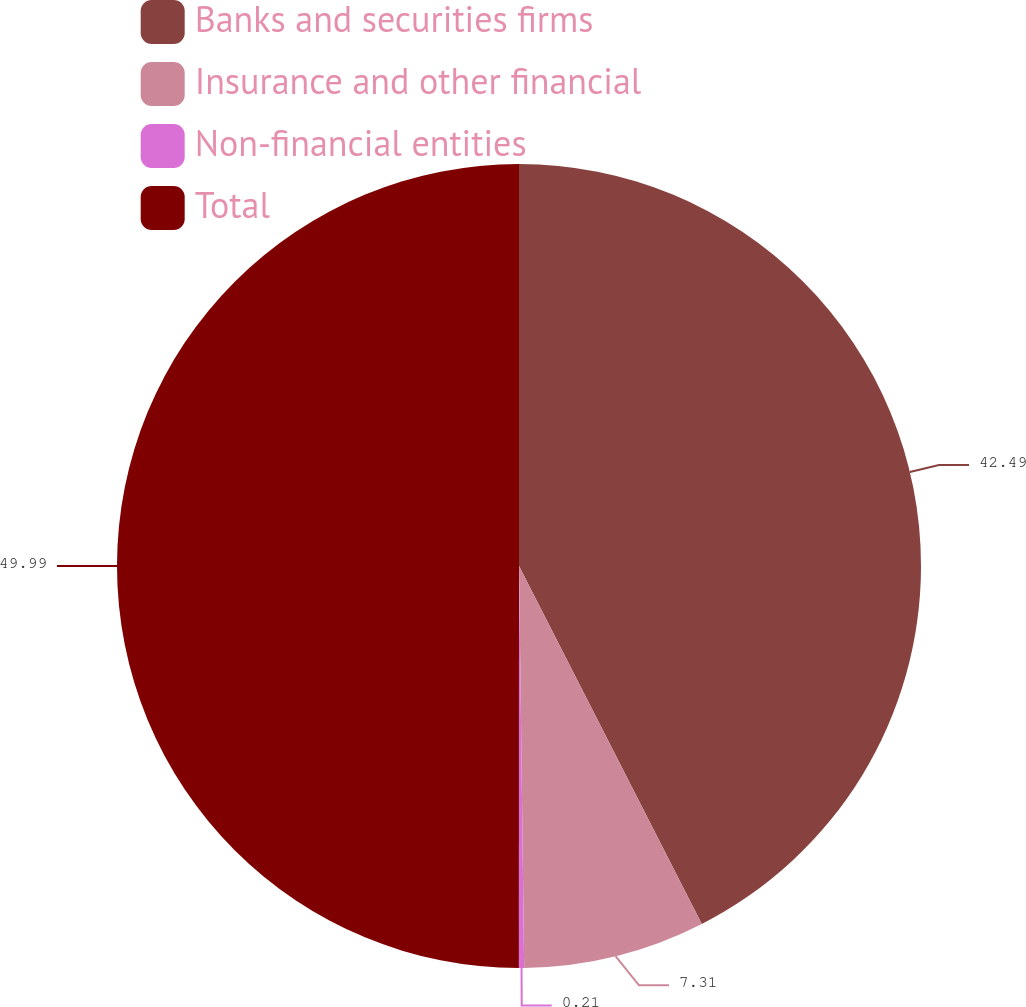Convert chart. <chart><loc_0><loc_0><loc_500><loc_500><pie_chart><fcel>Banks and securities firms<fcel>Insurance and other financial<fcel>Non-financial entities<fcel>Total<nl><fcel>42.49%<fcel>7.31%<fcel>0.21%<fcel>50.0%<nl></chart> 